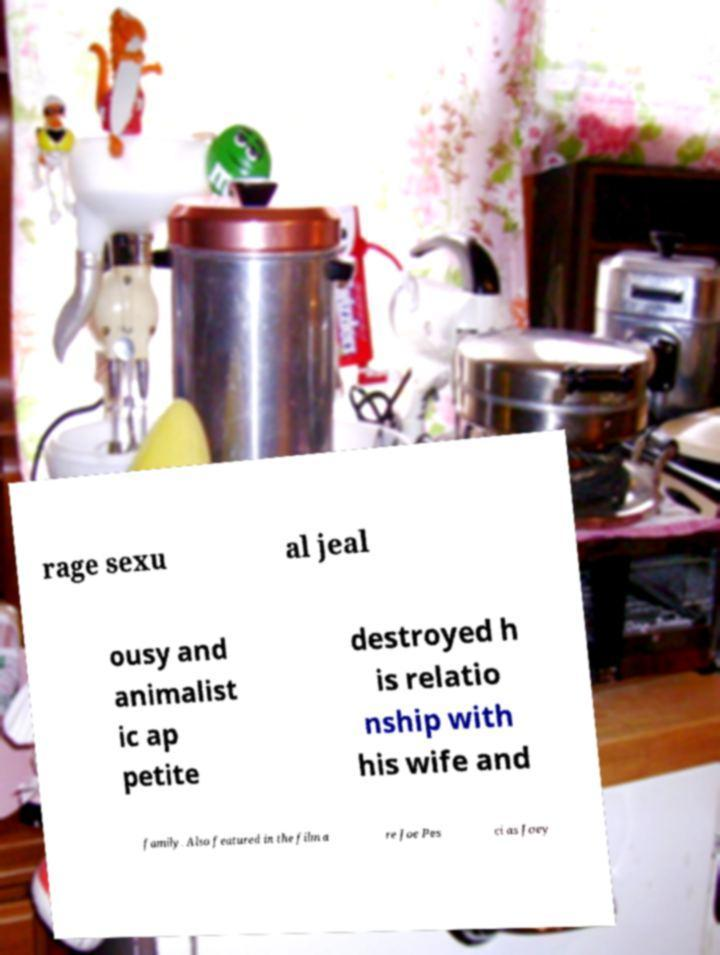What messages or text are displayed in this image? I need them in a readable, typed format. rage sexu al jeal ousy and animalist ic ap petite destroyed h is relatio nship with his wife and family. Also featured in the film a re Joe Pes ci as Joey 